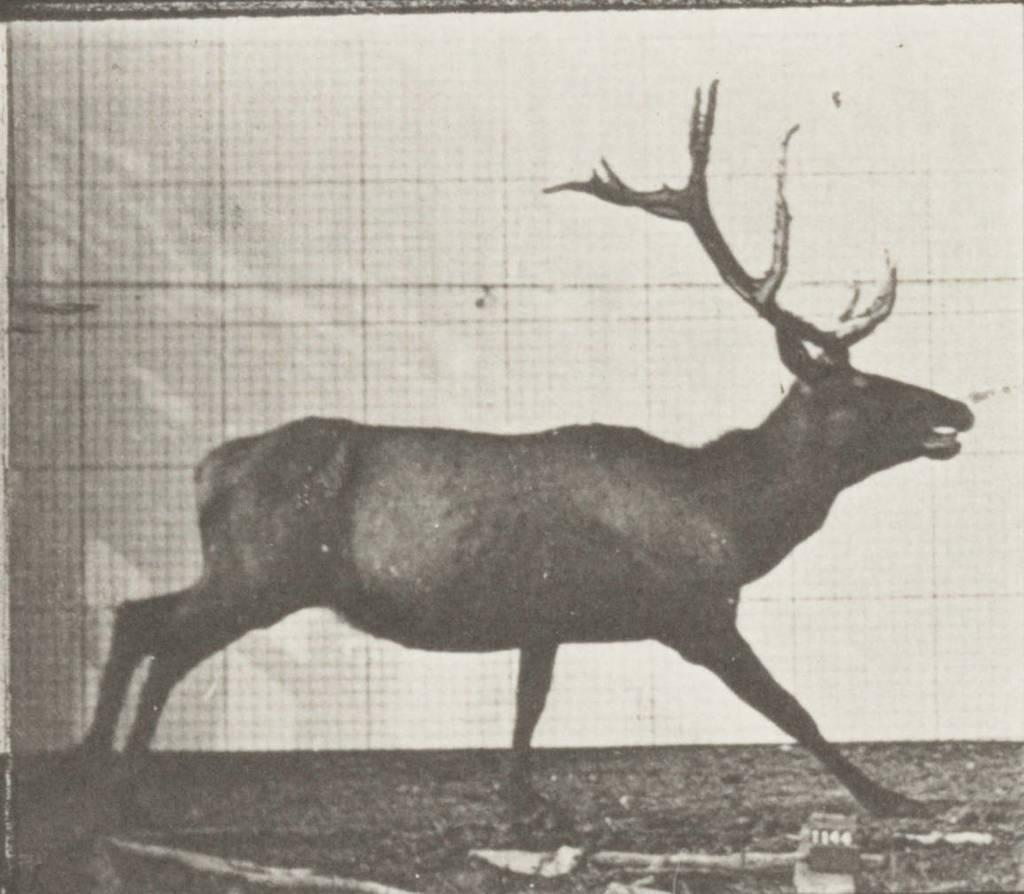What animal is depicted in the image? There is a picture of a deer in the image. Can you see a monkey fighting with the deer in the image? No, there is no monkey or fighting depicted in the image; it only features a picture of a deer. 